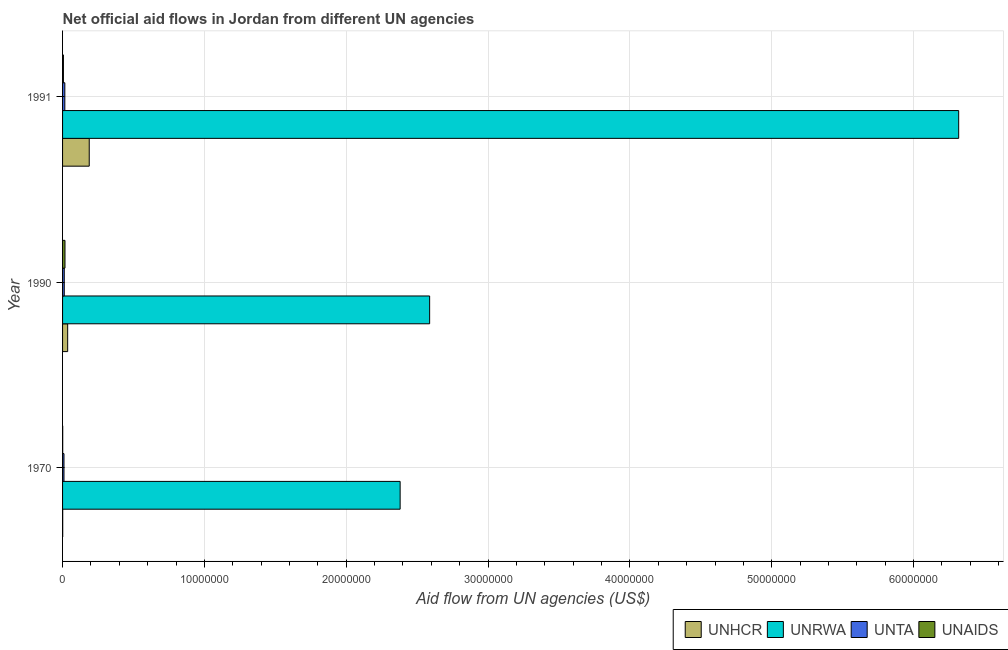In how many cases, is the number of bars for a given year not equal to the number of legend labels?
Provide a succinct answer. 0. What is the amount of aid given by unaids in 1991?
Provide a short and direct response. 6.00e+04. Across all years, what is the maximum amount of aid given by unta?
Offer a very short reply. 1.60e+05. Across all years, what is the minimum amount of aid given by unaids?
Your response must be concise. 10000. In which year was the amount of aid given by unaids maximum?
Provide a short and direct response. 1990. What is the total amount of aid given by unaids in the graph?
Offer a very short reply. 2.40e+05. What is the difference between the amount of aid given by unta in 1970 and that in 1991?
Offer a terse response. -6.00e+04. What is the difference between the amount of aid given by unta in 1991 and the amount of aid given by unrwa in 1990?
Your answer should be very brief. -2.57e+07. What is the average amount of aid given by unrwa per year?
Make the answer very short. 3.76e+07. In the year 1990, what is the difference between the amount of aid given by unrwa and amount of aid given by unaids?
Your response must be concise. 2.57e+07. In how many years, is the amount of aid given by unaids greater than 24000000 US$?
Make the answer very short. 0. What is the ratio of the amount of aid given by unaids in 1970 to that in 1991?
Ensure brevity in your answer.  0.17. Is the difference between the amount of aid given by unta in 1970 and 1990 greater than the difference between the amount of aid given by unrwa in 1970 and 1990?
Keep it short and to the point. Yes. What is the difference between the highest and the second highest amount of aid given by unhcr?
Provide a short and direct response. 1.52e+06. What is the difference between the highest and the lowest amount of aid given by unrwa?
Your answer should be very brief. 3.94e+07. In how many years, is the amount of aid given by unaids greater than the average amount of aid given by unaids taken over all years?
Provide a succinct answer. 1. Is the sum of the amount of aid given by unhcr in 1970 and 1991 greater than the maximum amount of aid given by unaids across all years?
Offer a terse response. Yes. Is it the case that in every year, the sum of the amount of aid given by unrwa and amount of aid given by unhcr is greater than the sum of amount of aid given by unta and amount of aid given by unaids?
Offer a terse response. No. What does the 3rd bar from the top in 1990 represents?
Give a very brief answer. UNRWA. What does the 1st bar from the bottom in 1970 represents?
Make the answer very short. UNHCR. Is it the case that in every year, the sum of the amount of aid given by unhcr and amount of aid given by unrwa is greater than the amount of aid given by unta?
Ensure brevity in your answer.  Yes. What is the difference between two consecutive major ticks on the X-axis?
Provide a short and direct response. 1.00e+07. Are the values on the major ticks of X-axis written in scientific E-notation?
Make the answer very short. No. Does the graph contain any zero values?
Give a very brief answer. No. Where does the legend appear in the graph?
Make the answer very short. Bottom right. What is the title of the graph?
Offer a very short reply. Net official aid flows in Jordan from different UN agencies. Does "Salary of employees" appear as one of the legend labels in the graph?
Give a very brief answer. No. What is the label or title of the X-axis?
Give a very brief answer. Aid flow from UN agencies (US$). What is the Aid flow from UN agencies (US$) in UNHCR in 1970?
Provide a succinct answer. 10000. What is the Aid flow from UN agencies (US$) in UNRWA in 1970?
Provide a short and direct response. 2.38e+07. What is the Aid flow from UN agencies (US$) in UNAIDS in 1970?
Your answer should be compact. 10000. What is the Aid flow from UN agencies (US$) in UNHCR in 1990?
Offer a very short reply. 3.60e+05. What is the Aid flow from UN agencies (US$) in UNRWA in 1990?
Make the answer very short. 2.59e+07. What is the Aid flow from UN agencies (US$) in UNTA in 1990?
Offer a very short reply. 1.20e+05. What is the Aid flow from UN agencies (US$) in UNAIDS in 1990?
Your answer should be very brief. 1.70e+05. What is the Aid flow from UN agencies (US$) of UNHCR in 1991?
Offer a terse response. 1.88e+06. What is the Aid flow from UN agencies (US$) in UNRWA in 1991?
Offer a terse response. 6.32e+07. What is the Aid flow from UN agencies (US$) in UNTA in 1991?
Provide a succinct answer. 1.60e+05. What is the Aid flow from UN agencies (US$) in UNAIDS in 1991?
Ensure brevity in your answer.  6.00e+04. Across all years, what is the maximum Aid flow from UN agencies (US$) in UNHCR?
Provide a succinct answer. 1.88e+06. Across all years, what is the maximum Aid flow from UN agencies (US$) of UNRWA?
Your response must be concise. 6.32e+07. Across all years, what is the maximum Aid flow from UN agencies (US$) in UNTA?
Give a very brief answer. 1.60e+05. Across all years, what is the maximum Aid flow from UN agencies (US$) of UNAIDS?
Make the answer very short. 1.70e+05. Across all years, what is the minimum Aid flow from UN agencies (US$) of UNHCR?
Offer a terse response. 10000. Across all years, what is the minimum Aid flow from UN agencies (US$) in UNRWA?
Provide a succinct answer. 2.38e+07. Across all years, what is the minimum Aid flow from UN agencies (US$) in UNTA?
Offer a very short reply. 1.00e+05. Across all years, what is the minimum Aid flow from UN agencies (US$) in UNAIDS?
Keep it short and to the point. 10000. What is the total Aid flow from UN agencies (US$) in UNHCR in the graph?
Give a very brief answer. 2.25e+06. What is the total Aid flow from UN agencies (US$) in UNRWA in the graph?
Keep it short and to the point. 1.13e+08. What is the total Aid flow from UN agencies (US$) of UNTA in the graph?
Ensure brevity in your answer.  3.80e+05. What is the difference between the Aid flow from UN agencies (US$) in UNHCR in 1970 and that in 1990?
Offer a very short reply. -3.50e+05. What is the difference between the Aid flow from UN agencies (US$) of UNRWA in 1970 and that in 1990?
Ensure brevity in your answer.  -2.08e+06. What is the difference between the Aid flow from UN agencies (US$) in UNTA in 1970 and that in 1990?
Give a very brief answer. -2.00e+04. What is the difference between the Aid flow from UN agencies (US$) in UNAIDS in 1970 and that in 1990?
Give a very brief answer. -1.60e+05. What is the difference between the Aid flow from UN agencies (US$) in UNHCR in 1970 and that in 1991?
Your answer should be compact. -1.87e+06. What is the difference between the Aid flow from UN agencies (US$) of UNRWA in 1970 and that in 1991?
Offer a very short reply. -3.94e+07. What is the difference between the Aid flow from UN agencies (US$) of UNHCR in 1990 and that in 1991?
Ensure brevity in your answer.  -1.52e+06. What is the difference between the Aid flow from UN agencies (US$) in UNRWA in 1990 and that in 1991?
Your answer should be very brief. -3.73e+07. What is the difference between the Aid flow from UN agencies (US$) in UNTA in 1990 and that in 1991?
Offer a terse response. -4.00e+04. What is the difference between the Aid flow from UN agencies (US$) in UNAIDS in 1990 and that in 1991?
Keep it short and to the point. 1.10e+05. What is the difference between the Aid flow from UN agencies (US$) in UNHCR in 1970 and the Aid flow from UN agencies (US$) in UNRWA in 1990?
Offer a very short reply. -2.59e+07. What is the difference between the Aid flow from UN agencies (US$) in UNHCR in 1970 and the Aid flow from UN agencies (US$) in UNTA in 1990?
Provide a short and direct response. -1.10e+05. What is the difference between the Aid flow from UN agencies (US$) of UNRWA in 1970 and the Aid flow from UN agencies (US$) of UNTA in 1990?
Offer a very short reply. 2.37e+07. What is the difference between the Aid flow from UN agencies (US$) of UNRWA in 1970 and the Aid flow from UN agencies (US$) of UNAIDS in 1990?
Provide a short and direct response. 2.36e+07. What is the difference between the Aid flow from UN agencies (US$) in UNHCR in 1970 and the Aid flow from UN agencies (US$) in UNRWA in 1991?
Give a very brief answer. -6.32e+07. What is the difference between the Aid flow from UN agencies (US$) of UNRWA in 1970 and the Aid flow from UN agencies (US$) of UNTA in 1991?
Offer a terse response. 2.36e+07. What is the difference between the Aid flow from UN agencies (US$) in UNRWA in 1970 and the Aid flow from UN agencies (US$) in UNAIDS in 1991?
Give a very brief answer. 2.37e+07. What is the difference between the Aid flow from UN agencies (US$) of UNTA in 1970 and the Aid flow from UN agencies (US$) of UNAIDS in 1991?
Offer a very short reply. 4.00e+04. What is the difference between the Aid flow from UN agencies (US$) in UNHCR in 1990 and the Aid flow from UN agencies (US$) in UNRWA in 1991?
Give a very brief answer. -6.28e+07. What is the difference between the Aid flow from UN agencies (US$) of UNRWA in 1990 and the Aid flow from UN agencies (US$) of UNTA in 1991?
Give a very brief answer. 2.57e+07. What is the difference between the Aid flow from UN agencies (US$) of UNRWA in 1990 and the Aid flow from UN agencies (US$) of UNAIDS in 1991?
Your response must be concise. 2.58e+07. What is the average Aid flow from UN agencies (US$) in UNHCR per year?
Ensure brevity in your answer.  7.50e+05. What is the average Aid flow from UN agencies (US$) in UNRWA per year?
Provide a succinct answer. 3.76e+07. What is the average Aid flow from UN agencies (US$) of UNTA per year?
Provide a succinct answer. 1.27e+05. In the year 1970, what is the difference between the Aid flow from UN agencies (US$) of UNHCR and Aid flow from UN agencies (US$) of UNRWA?
Make the answer very short. -2.38e+07. In the year 1970, what is the difference between the Aid flow from UN agencies (US$) of UNRWA and Aid flow from UN agencies (US$) of UNTA?
Ensure brevity in your answer.  2.37e+07. In the year 1970, what is the difference between the Aid flow from UN agencies (US$) in UNRWA and Aid flow from UN agencies (US$) in UNAIDS?
Provide a succinct answer. 2.38e+07. In the year 1990, what is the difference between the Aid flow from UN agencies (US$) in UNHCR and Aid flow from UN agencies (US$) in UNRWA?
Provide a short and direct response. -2.55e+07. In the year 1990, what is the difference between the Aid flow from UN agencies (US$) in UNRWA and Aid flow from UN agencies (US$) in UNTA?
Your answer should be very brief. 2.58e+07. In the year 1990, what is the difference between the Aid flow from UN agencies (US$) of UNRWA and Aid flow from UN agencies (US$) of UNAIDS?
Your answer should be compact. 2.57e+07. In the year 1990, what is the difference between the Aid flow from UN agencies (US$) of UNTA and Aid flow from UN agencies (US$) of UNAIDS?
Provide a succinct answer. -5.00e+04. In the year 1991, what is the difference between the Aid flow from UN agencies (US$) of UNHCR and Aid flow from UN agencies (US$) of UNRWA?
Ensure brevity in your answer.  -6.13e+07. In the year 1991, what is the difference between the Aid flow from UN agencies (US$) in UNHCR and Aid flow from UN agencies (US$) in UNTA?
Offer a terse response. 1.72e+06. In the year 1991, what is the difference between the Aid flow from UN agencies (US$) in UNHCR and Aid flow from UN agencies (US$) in UNAIDS?
Ensure brevity in your answer.  1.82e+06. In the year 1991, what is the difference between the Aid flow from UN agencies (US$) of UNRWA and Aid flow from UN agencies (US$) of UNTA?
Provide a short and direct response. 6.30e+07. In the year 1991, what is the difference between the Aid flow from UN agencies (US$) of UNRWA and Aid flow from UN agencies (US$) of UNAIDS?
Offer a terse response. 6.31e+07. In the year 1991, what is the difference between the Aid flow from UN agencies (US$) in UNTA and Aid flow from UN agencies (US$) in UNAIDS?
Give a very brief answer. 1.00e+05. What is the ratio of the Aid flow from UN agencies (US$) of UNHCR in 1970 to that in 1990?
Offer a very short reply. 0.03. What is the ratio of the Aid flow from UN agencies (US$) in UNRWA in 1970 to that in 1990?
Your answer should be compact. 0.92. What is the ratio of the Aid flow from UN agencies (US$) in UNTA in 1970 to that in 1990?
Your answer should be compact. 0.83. What is the ratio of the Aid flow from UN agencies (US$) of UNAIDS in 1970 to that in 1990?
Provide a short and direct response. 0.06. What is the ratio of the Aid flow from UN agencies (US$) of UNHCR in 1970 to that in 1991?
Your answer should be compact. 0.01. What is the ratio of the Aid flow from UN agencies (US$) in UNRWA in 1970 to that in 1991?
Provide a succinct answer. 0.38. What is the ratio of the Aid flow from UN agencies (US$) in UNTA in 1970 to that in 1991?
Ensure brevity in your answer.  0.62. What is the ratio of the Aid flow from UN agencies (US$) of UNHCR in 1990 to that in 1991?
Give a very brief answer. 0.19. What is the ratio of the Aid flow from UN agencies (US$) of UNRWA in 1990 to that in 1991?
Your response must be concise. 0.41. What is the ratio of the Aid flow from UN agencies (US$) of UNTA in 1990 to that in 1991?
Make the answer very short. 0.75. What is the ratio of the Aid flow from UN agencies (US$) of UNAIDS in 1990 to that in 1991?
Provide a short and direct response. 2.83. What is the difference between the highest and the second highest Aid flow from UN agencies (US$) of UNHCR?
Keep it short and to the point. 1.52e+06. What is the difference between the highest and the second highest Aid flow from UN agencies (US$) of UNRWA?
Provide a short and direct response. 3.73e+07. What is the difference between the highest and the second highest Aid flow from UN agencies (US$) of UNAIDS?
Make the answer very short. 1.10e+05. What is the difference between the highest and the lowest Aid flow from UN agencies (US$) of UNHCR?
Make the answer very short. 1.87e+06. What is the difference between the highest and the lowest Aid flow from UN agencies (US$) of UNRWA?
Make the answer very short. 3.94e+07. What is the difference between the highest and the lowest Aid flow from UN agencies (US$) of UNAIDS?
Your answer should be very brief. 1.60e+05. 